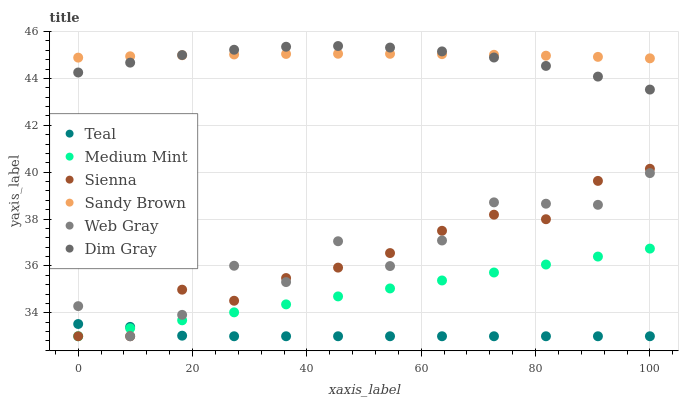Does Teal have the minimum area under the curve?
Answer yes or no. Yes. Does Sandy Brown have the maximum area under the curve?
Answer yes or no. Yes. Does Dim Gray have the minimum area under the curve?
Answer yes or no. No. Does Dim Gray have the maximum area under the curve?
Answer yes or no. No. Is Medium Mint the smoothest?
Answer yes or no. Yes. Is Web Gray the roughest?
Answer yes or no. Yes. Is Dim Gray the smoothest?
Answer yes or no. No. Is Dim Gray the roughest?
Answer yes or no. No. Does Medium Mint have the lowest value?
Answer yes or no. Yes. Does Dim Gray have the lowest value?
Answer yes or no. No. Does Dim Gray have the highest value?
Answer yes or no. Yes. Does Sienna have the highest value?
Answer yes or no. No. Is Web Gray less than Sandy Brown?
Answer yes or no. Yes. Is Sandy Brown greater than Teal?
Answer yes or no. Yes. Does Web Gray intersect Medium Mint?
Answer yes or no. Yes. Is Web Gray less than Medium Mint?
Answer yes or no. No. Is Web Gray greater than Medium Mint?
Answer yes or no. No. Does Web Gray intersect Sandy Brown?
Answer yes or no. No. 